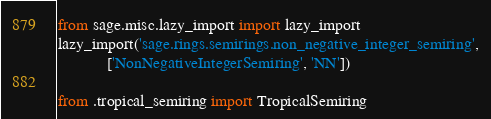Convert code to text. <code><loc_0><loc_0><loc_500><loc_500><_Python_>
from sage.misc.lazy_import import lazy_import
lazy_import('sage.rings.semirings.non_negative_integer_semiring',
            ['NonNegativeIntegerSemiring', 'NN'])

from .tropical_semiring import TropicalSemiring
</code> 